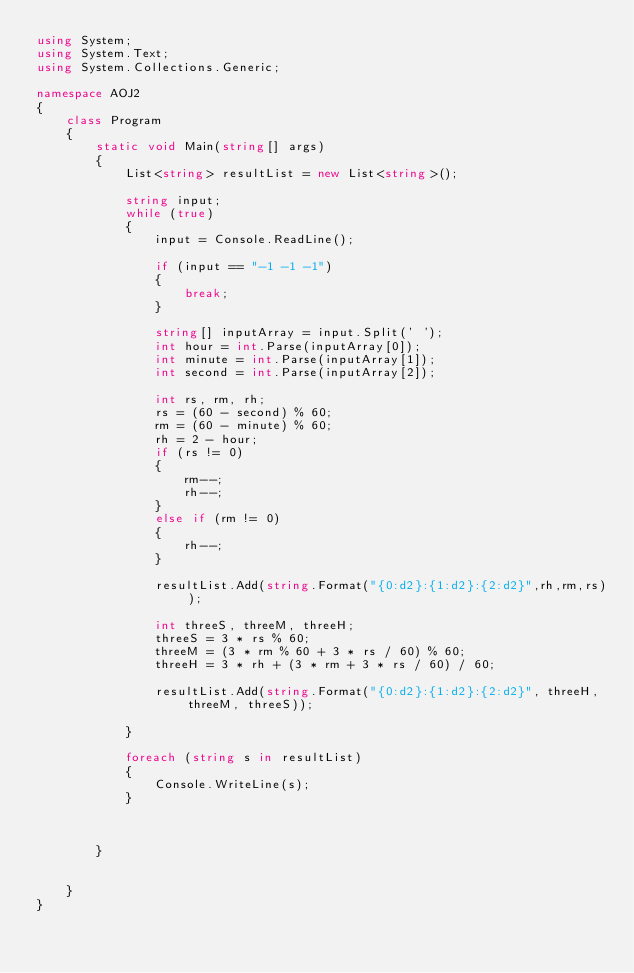Convert code to text. <code><loc_0><loc_0><loc_500><loc_500><_C#_>using System;
using System.Text;
using System.Collections.Generic;

namespace AOJ2
{
    class Program
    {
        static void Main(string[] args)
        {
            List<string> resultList = new List<string>();

            string input;
            while (true)
            {
                input = Console.ReadLine();

                if (input == "-1 -1 -1")
                {
                    break;
                }

                string[] inputArray = input.Split(' ');
                int hour = int.Parse(inputArray[0]);
                int minute = int.Parse(inputArray[1]);
                int second = int.Parse(inputArray[2]);

                int rs, rm, rh;
                rs = (60 - second) % 60;
                rm = (60 - minute) % 60;
                rh = 2 - hour;
                if (rs != 0)
                {
                    rm--;
                    rh--;
                }
                else if (rm != 0)
                {
                    rh--;
                }
    
                resultList.Add(string.Format("{0:d2}:{1:d2}:{2:d2}",rh,rm,rs));

                int threeS, threeM, threeH;
                threeS = 3 * rs % 60;
                threeM = (3 * rm % 60 + 3 * rs / 60) % 60;
                threeH = 3 * rh + (3 * rm + 3 * rs / 60) / 60;

                resultList.Add(string.Format("{0:d2}:{1:d2}:{2:d2}", threeH, threeM, threeS));

            }

            foreach (string s in resultList)
            {
                Console.WriteLine(s);
            }



        }


    }
}</code> 